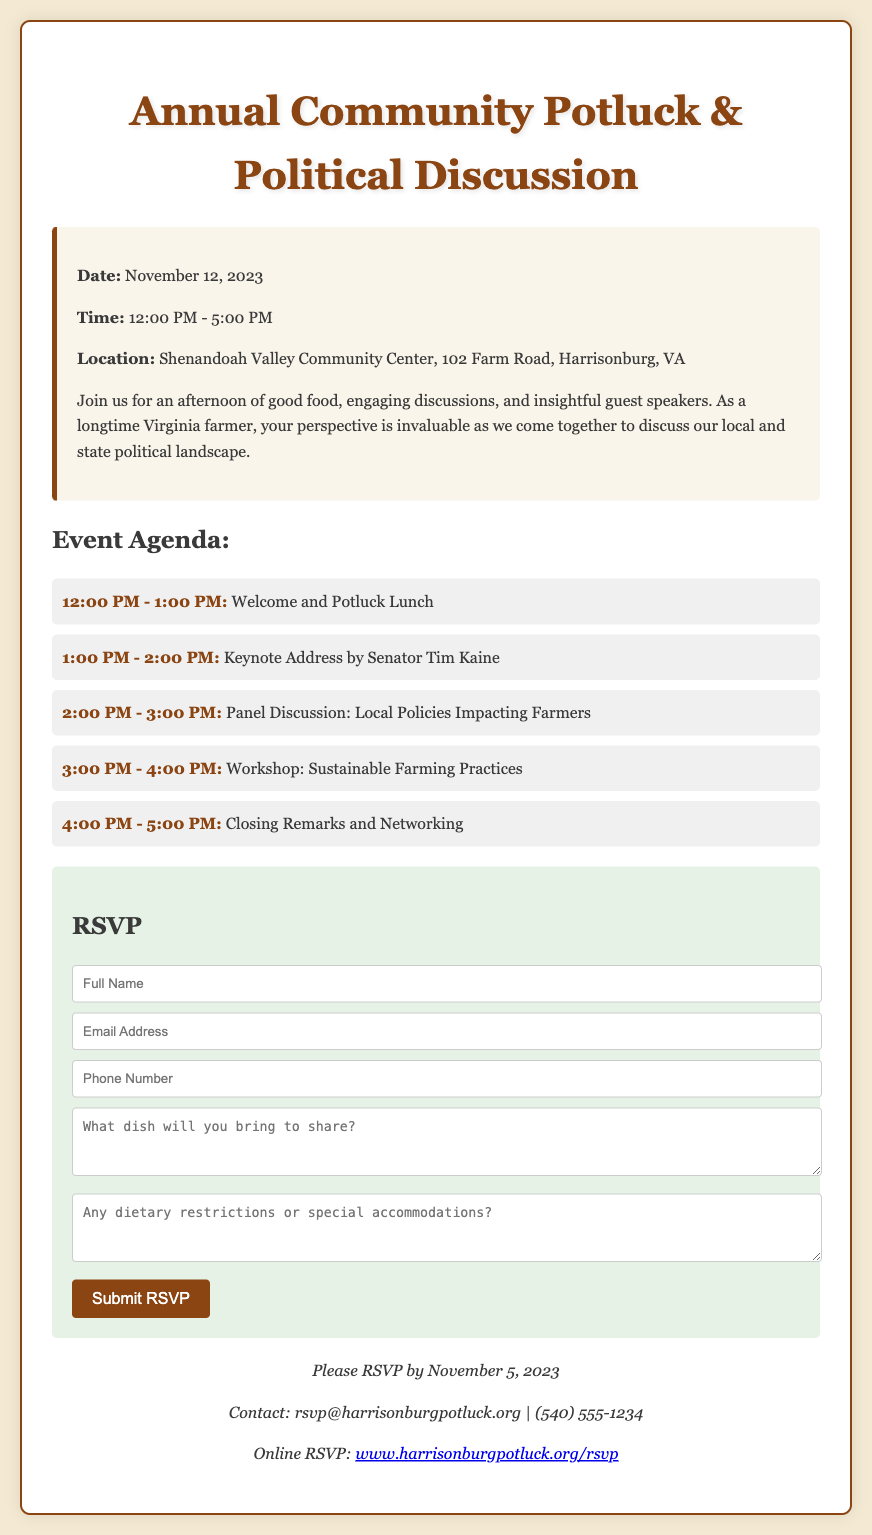what is the date of the event? The event is scheduled for November 12, 2023.
Answer: November 12, 2023 what time does the event start? The event begins at 12:00 PM.
Answer: 12:00 PM who is giving the keynote address? The keynote address is by Senator Tim Kaine.
Answer: Senator Tim Kaine what is the location of the event? The event will be held at the Shenandoah Valley Community Center, 102 Farm Road, Harrisonburg, VA.
Answer: Shenandoah Valley Community Center, 102 Farm Road, Harrisonburg, VA what is the final agenda item? The final agenda item is "Closing Remarks and Networking".
Answer: Closing Remarks and Networking how many hours will the event last? The event lasts from 12:00 PM to 5:00 PM, which is a total of 5 hours.
Answer: 5 hours what should attendees do to RSVP? Attendees must fill out the RSVP form provided in the document.
Answer: Fill out the RSVP form when is the deadline to RSVP? The deadline to RSVP is November 5, 2023.
Answer: November 5, 2023 what type of food will be served? The event features a potluck lunch with homemade dishes.
Answer: Homemade dishes 